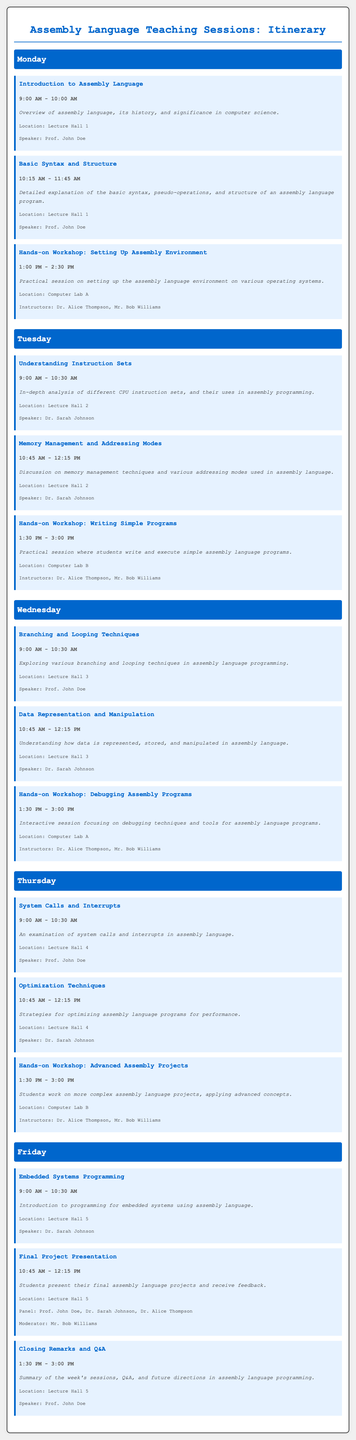What is the title of the itinerary? The title is specified at the top of the document.
Answer: Assembly Language Teaching Sessions: Itinerary Who is the speaker for the "Introduction to Assembly Language" session? The speaker's name is listed in the session details.
Answer: Prof. John Doe What time does the "Understanding Instruction Sets" session start? The start time can be found in the session details.
Answer: 9:00 AM Which location is assigned for the "Hands-on Workshop: Writing Simple Programs"? The location is indicated within the session description.
Answer: Computer Lab B What are the names of the instructors for the "Hands-on Workshop: Debugging Assembly Programs"? The instructors' names are provided in the workshop session information.
Answer: Dr. Alice Thompson, Mr. Bob Williams On which day is the "Final Project Presentation" scheduled? The day can be identified by reviewing the session order.
Answer: Friday How long is the "Optimization Techniques" session? The duration can be calculated from the provided start and end times in the timetable.
Answer: 1 hour 30 minutes Which session focuses on "Embedded Systems Programming"? The specific session is highlighted along with its details in the document.
Answer: Embedded Systems Programming What is the last session of the week? The last session is indicated in the Friday schedule section.
Answer: Closing Remarks and Q&A 